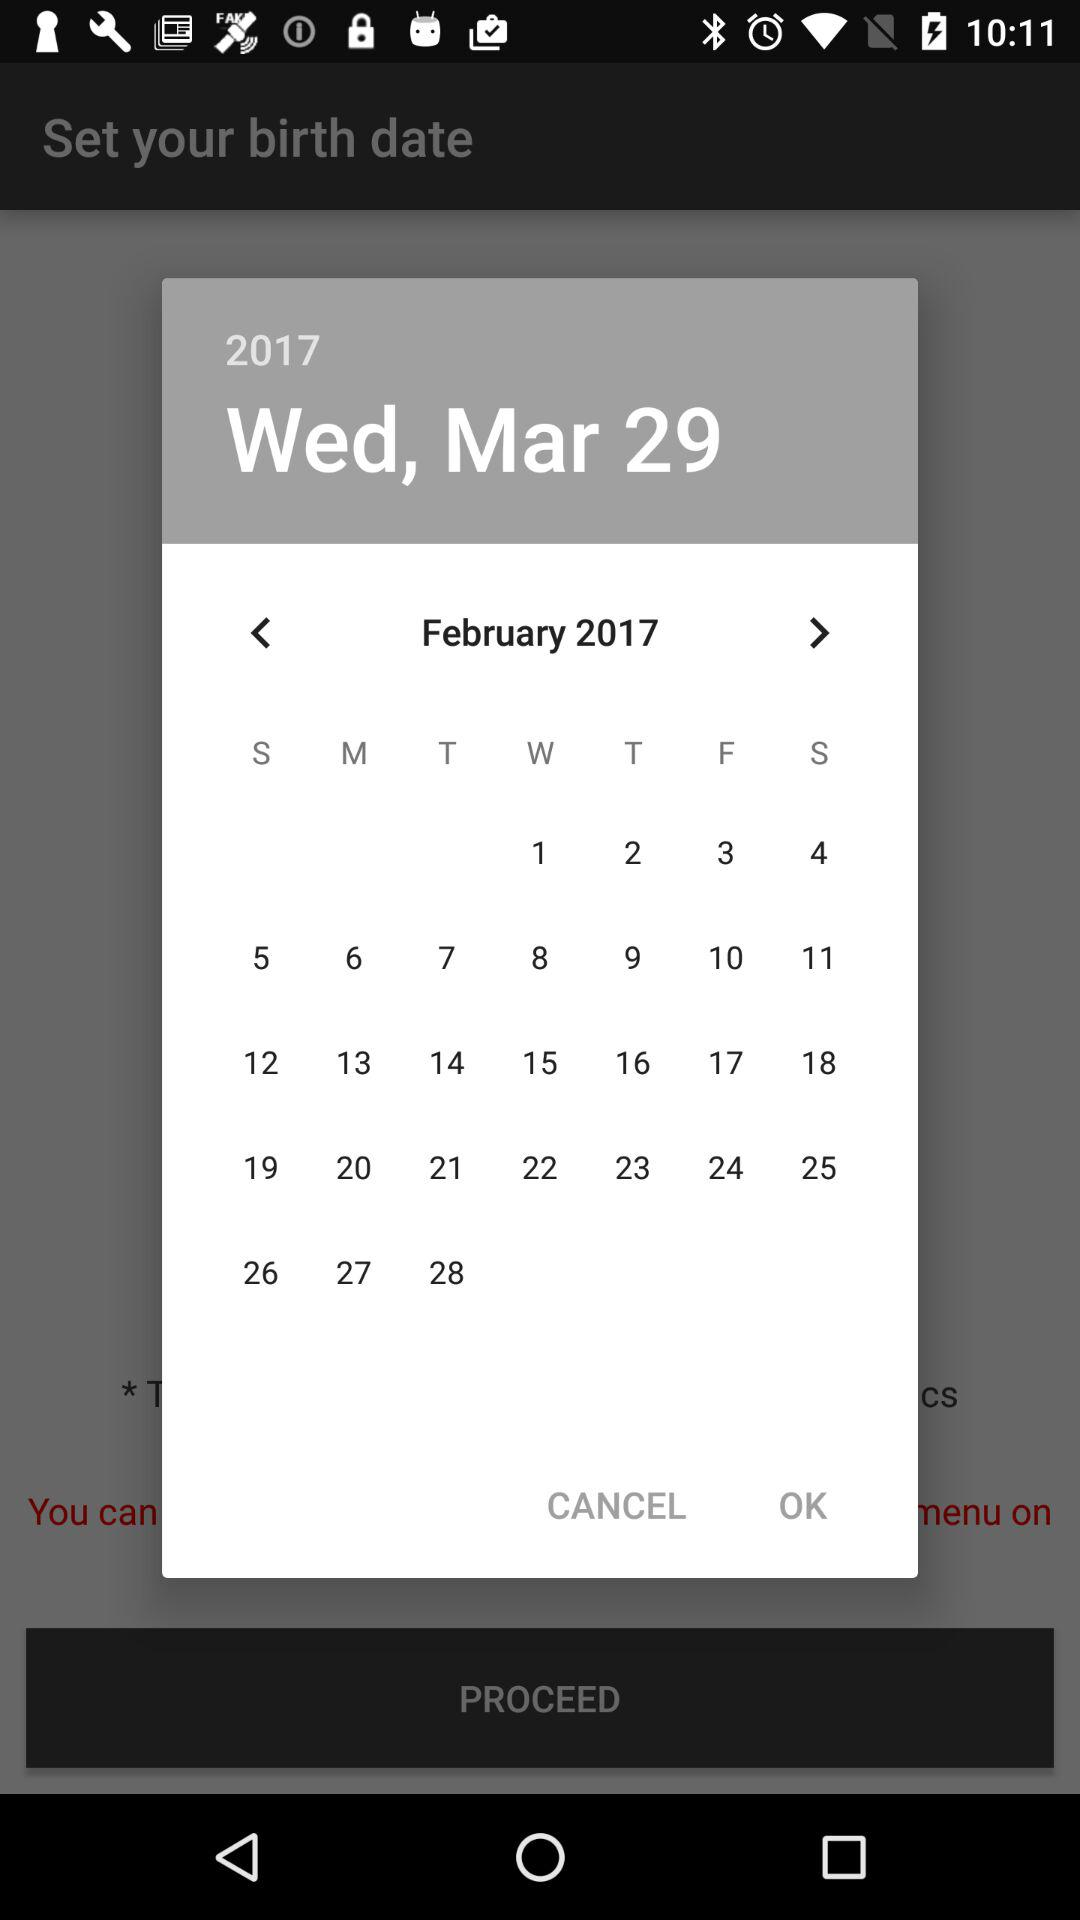What is the date on Wednesday? The date on Wednesday is March 29, 2017. 